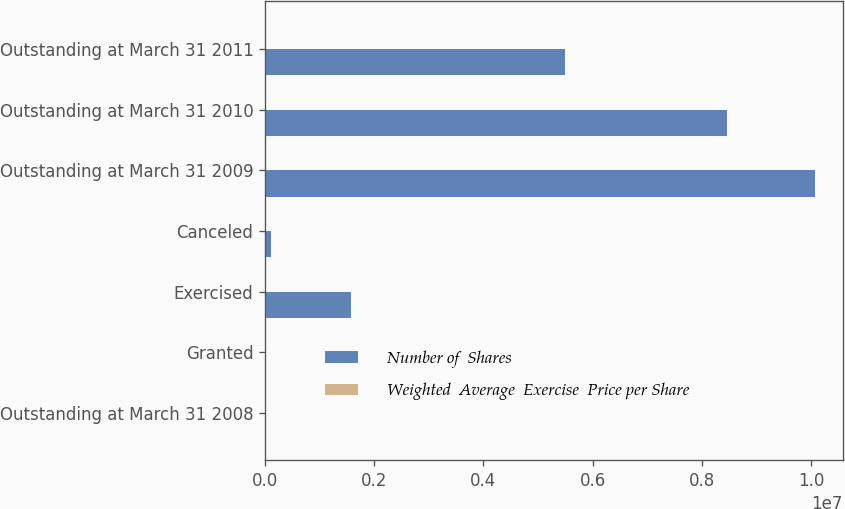Convert chart. <chart><loc_0><loc_0><loc_500><loc_500><stacked_bar_chart><ecel><fcel>Outstanding at March 31 2008<fcel>Granted<fcel>Exercised<fcel>Canceled<fcel>Outstanding at March 31 2009<fcel>Outstanding at March 31 2010<fcel>Outstanding at March 31 2011<nl><fcel>Number of  Shares<fcel>33.9<fcel>24000<fcel>1.57318e+06<fcel>101669<fcel>1.00815e+07<fcel>8.45978e+06<fcel>5.49692e+06<nl><fcel>Weighted  Average  Exercise  Price per Share<fcel>23.14<fcel>33.9<fcel>16.33<fcel>26.27<fcel>24.2<fcel>24.52<fcel>25.21<nl></chart> 